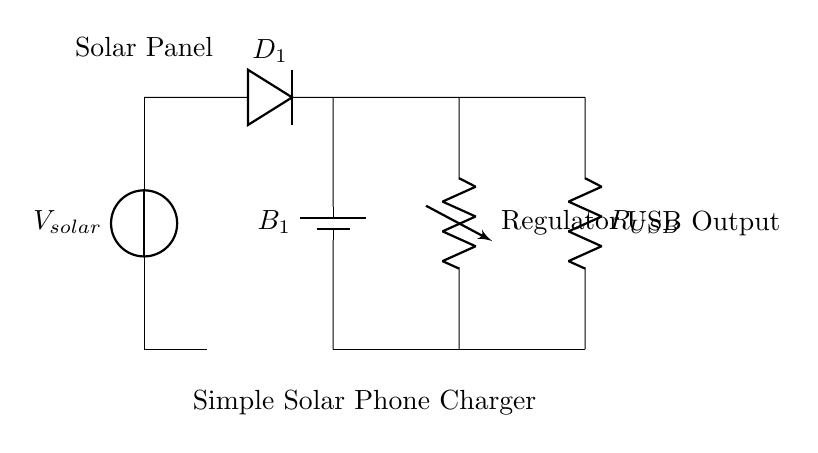What type of energy source is used in this circuit? The energy source is a solar panel, which converts solar energy into electrical energy. This can be identified from the first component labeled in the circuit.
Answer: Solar panel What is the purpose of the diode in the circuit? The diode is used to allow current to flow in one direction while preventing reverse current, thereby protecting the battery from potential damage. This is a fundamental property of diodes and is indicated in the diagram.
Answer: Prevents reverse current What component stores energy in the circuit? The battery is the component that stores electrical energy collected from the solar panel for later use in charging a phone. This can be directly seen from the labeled component in the diagram.
Answer: Battery What is the output voltage type provided by this circuit for charging devices? The output voltage is typically USB voltage, which is standardized at five volts for charging most small electronic devices. This is inferred from the labeled USB output section in the circuit.
Answer: Five volts What is the function of the voltage regulator in this circuit? The voltage regulator ensures that the output voltage remains constant at a specified level, in this case, ensuring that the output is safe for USB charging. This is necessary for consistent performance, as indicated in the diagram.
Answer: Regulates voltage How many main components are visible in the diagram? There are five main components identifiable in the circuit, including the solar panel, diode, battery, voltage regulator, and USB output resistor. This is counted directly from the labeled elements in the diagram.
Answer: Five components 